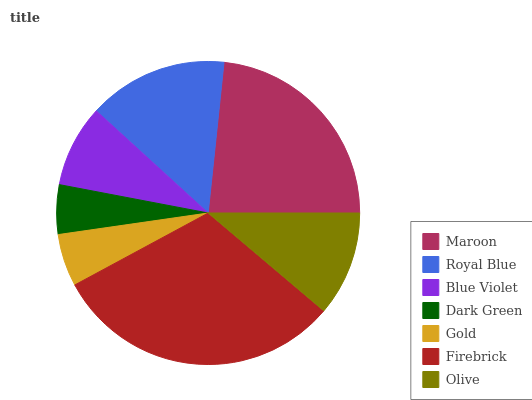Is Dark Green the minimum?
Answer yes or no. Yes. Is Firebrick the maximum?
Answer yes or no. Yes. Is Royal Blue the minimum?
Answer yes or no. No. Is Royal Blue the maximum?
Answer yes or no. No. Is Maroon greater than Royal Blue?
Answer yes or no. Yes. Is Royal Blue less than Maroon?
Answer yes or no. Yes. Is Royal Blue greater than Maroon?
Answer yes or no. No. Is Maroon less than Royal Blue?
Answer yes or no. No. Is Olive the high median?
Answer yes or no. Yes. Is Olive the low median?
Answer yes or no. Yes. Is Blue Violet the high median?
Answer yes or no. No. Is Maroon the low median?
Answer yes or no. No. 